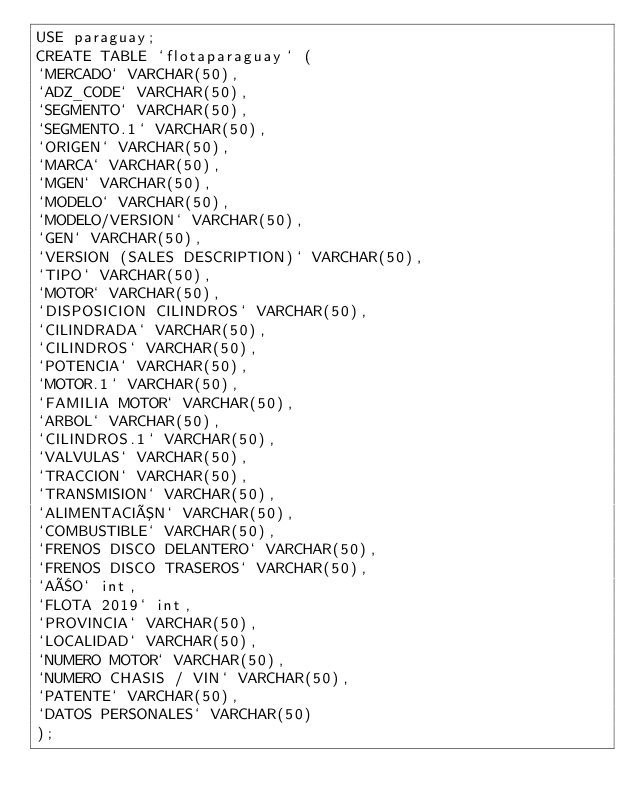<code> <loc_0><loc_0><loc_500><loc_500><_SQL_>USE paraguay;
CREATE TABLE `flotaparaguay` (
`MERCADO` VARCHAR(50),
`ADZ_CODE` VARCHAR(50),
`SEGMENTO` VARCHAR(50),
`SEGMENTO.1` VARCHAR(50),
`ORIGEN` VARCHAR(50),
`MARCA` VARCHAR(50),
`MGEN` VARCHAR(50),
`MODELO` VARCHAR(50),
`MODELO/VERSION` VARCHAR(50),
`GEN` VARCHAR(50),
`VERSION (SALES DESCRIPTION)` VARCHAR(50),
`TIPO` VARCHAR(50),
`MOTOR` VARCHAR(50),
`DISPOSICION CILINDROS` VARCHAR(50),
`CILINDRADA` VARCHAR(50),
`CILINDROS` VARCHAR(50),
`POTENCIA` VARCHAR(50),
`MOTOR.1` VARCHAR(50),
`FAMILIA MOTOR` VARCHAR(50),
`ARBOL` VARCHAR(50),
`CILINDROS.1` VARCHAR(50),
`VALVULAS` VARCHAR(50),
`TRACCION` VARCHAR(50),
`TRANSMISION` VARCHAR(50),
`ALIMENTACIÓN` VARCHAR(50),
`COMBUSTIBLE` VARCHAR(50),
`FRENOS DISCO DELANTERO` VARCHAR(50),
`FRENOS DISCO TRASEROS` VARCHAR(50),
`AÑO` int,
`FLOTA 2019` int,
`PROVINCIA` VARCHAR(50),
`LOCALIDAD` VARCHAR(50),
`NUMERO MOTOR` VARCHAR(50),
`NUMERO CHASIS / VIN` VARCHAR(50),
`PATENTE` VARCHAR(50),
`DATOS PERSONALES` VARCHAR(50)
);
</code> 